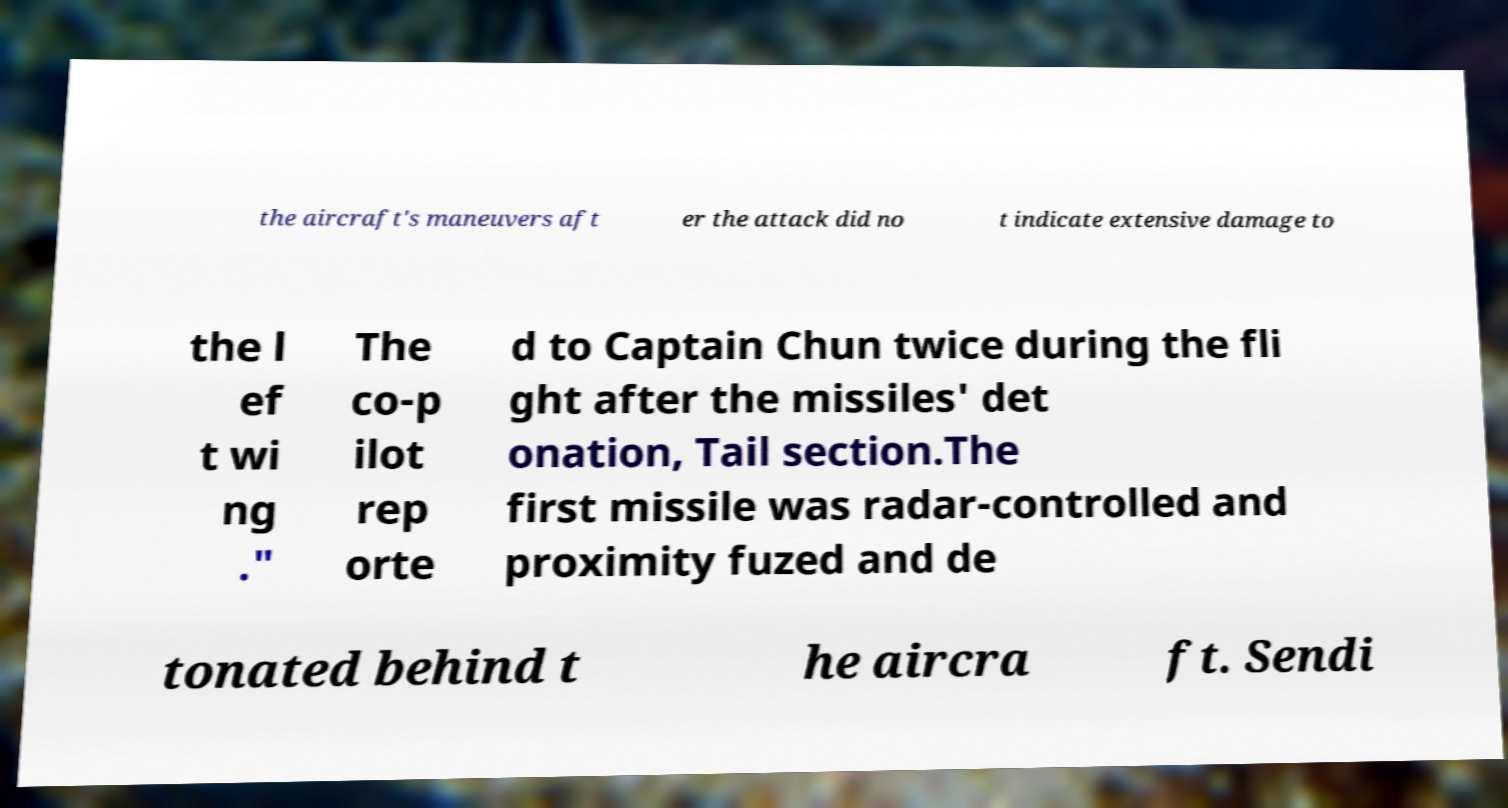I need the written content from this picture converted into text. Can you do that? the aircraft's maneuvers aft er the attack did no t indicate extensive damage to the l ef t wi ng ." The co-p ilot rep orte d to Captain Chun twice during the fli ght after the missiles' det onation, Tail section.The first missile was radar-controlled and proximity fuzed and de tonated behind t he aircra ft. Sendi 